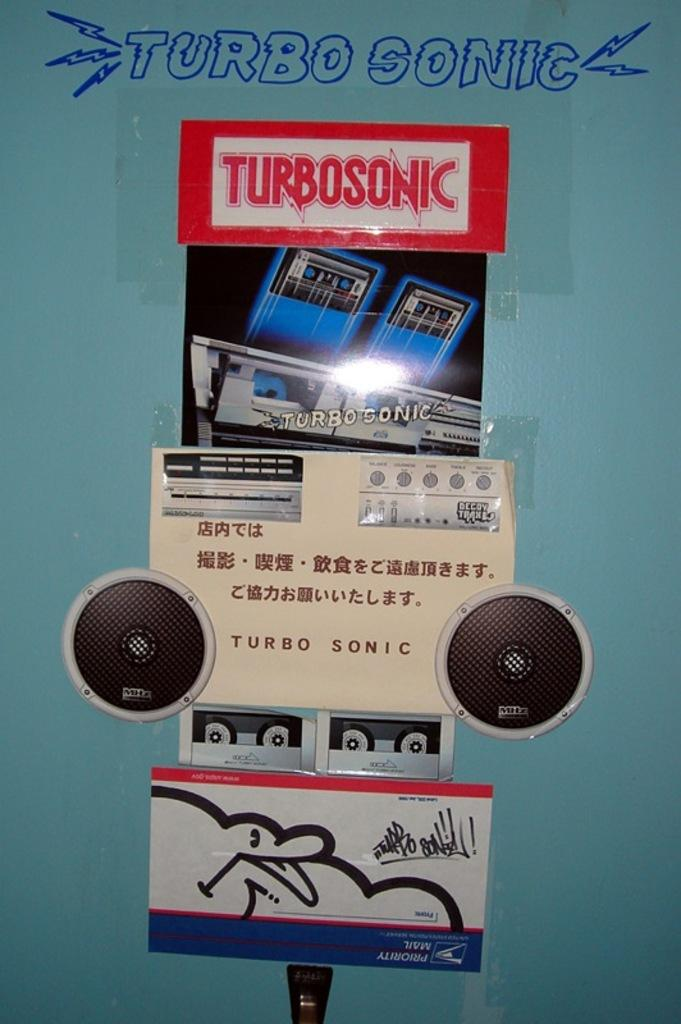<image>
Write a terse but informative summary of the picture. A display of signs and pictures promoting the Turbosonic product. 